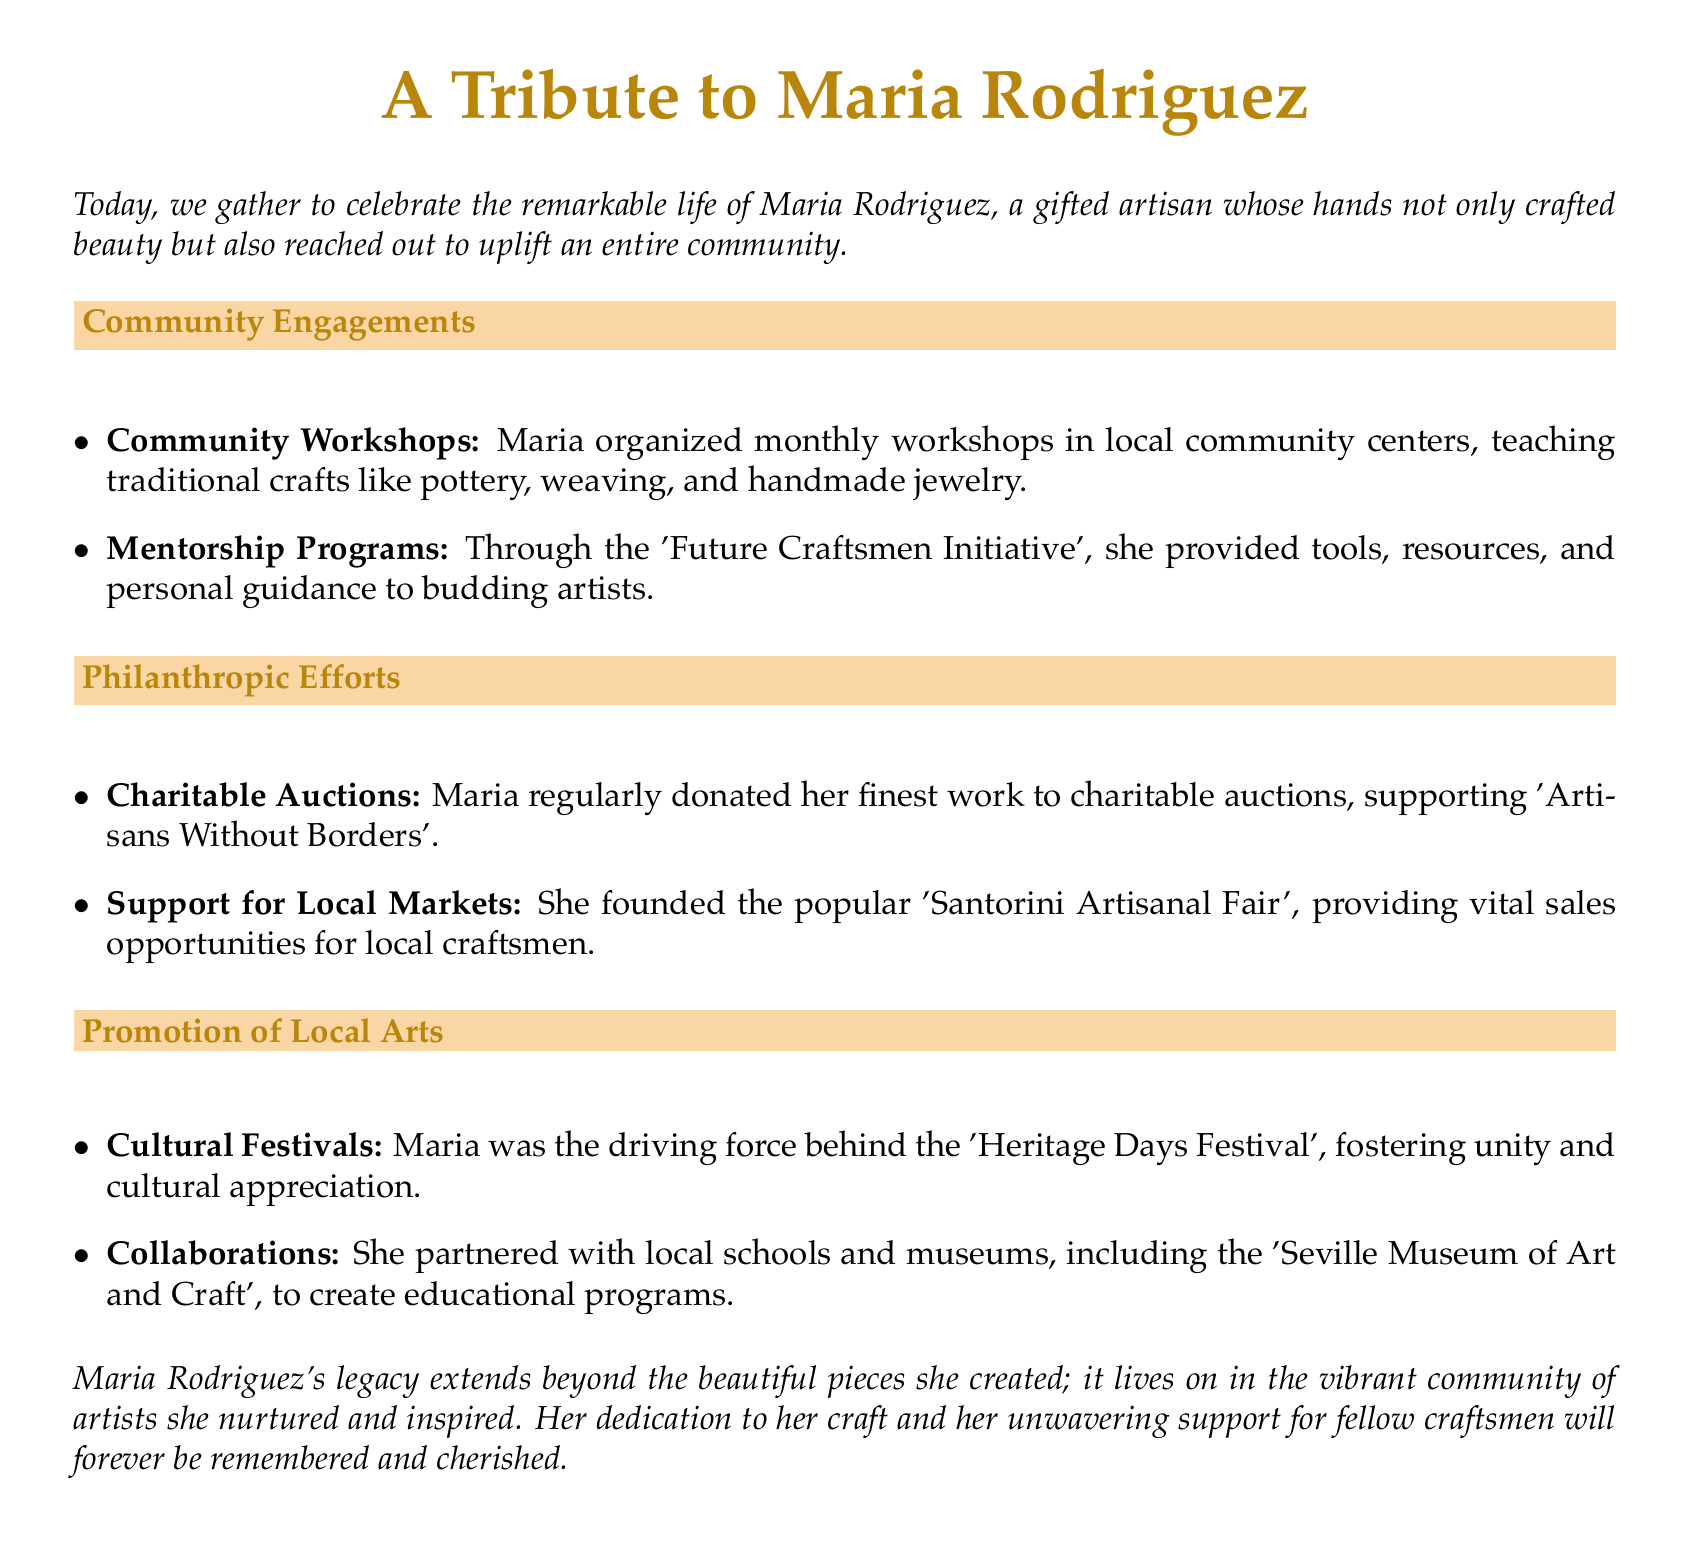What was Maria Rodriguez known for? Maria was a gifted artisan known for her craftsmanship and community efforts.
Answer: gifted artisan How often did Maria organize community workshops? The document states she organized workshops monthly.
Answer: monthly What initiative did she create for budding artists? The document mentions the 'Future Craftsmen Initiative'.
Answer: Future Craftsmen Initiative What type of events did Maria support through charitable auctions? She donated her work to support 'Artisans Without Borders'.
Answer: Artisans Without Borders What was the name of the fair she founded? The document refers to the fair as the 'Santorini Artisanal Fair'.
Answer: Santorini Artisanal Fair How did Maria promote understanding of local arts? She was the driving force behind the 'Heritage Days Festival'.
Answer: Heritage Days Festival What organization partnered with local schools and museums? The document cites the 'Seville Museum of Art and Craft'.
Answer: Seville Museum of Art and Craft What did Maria's legacy extend beyond? Her legacy goes beyond the pieces she created, focusing on her impact on the community.
Answer: beautiful pieces she created What was the overall theme of the eulogy? The eulogy celebrates Maria's life and contributions to the artisan community.
Answer: Maria's life and contributions 